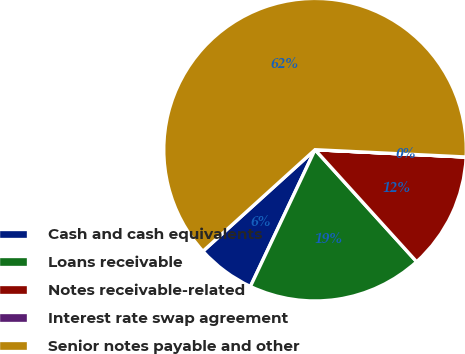Convert chart. <chart><loc_0><loc_0><loc_500><loc_500><pie_chart><fcel>Cash and cash equivalents<fcel>Loans receivable<fcel>Notes receivable-related<fcel>Interest rate swap agreement<fcel>Senior notes payable and other<nl><fcel>6.26%<fcel>18.75%<fcel>12.5%<fcel>0.01%<fcel>62.48%<nl></chart> 